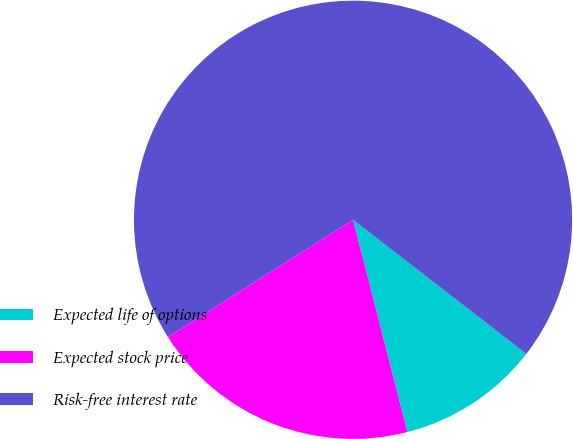Convert chart to OTSL. <chart><loc_0><loc_0><loc_500><loc_500><pie_chart><fcel>Expected life of options<fcel>Expected stock price<fcel>Risk-free interest rate<nl><fcel>10.53%<fcel>20.0%<fcel>69.47%<nl></chart> 